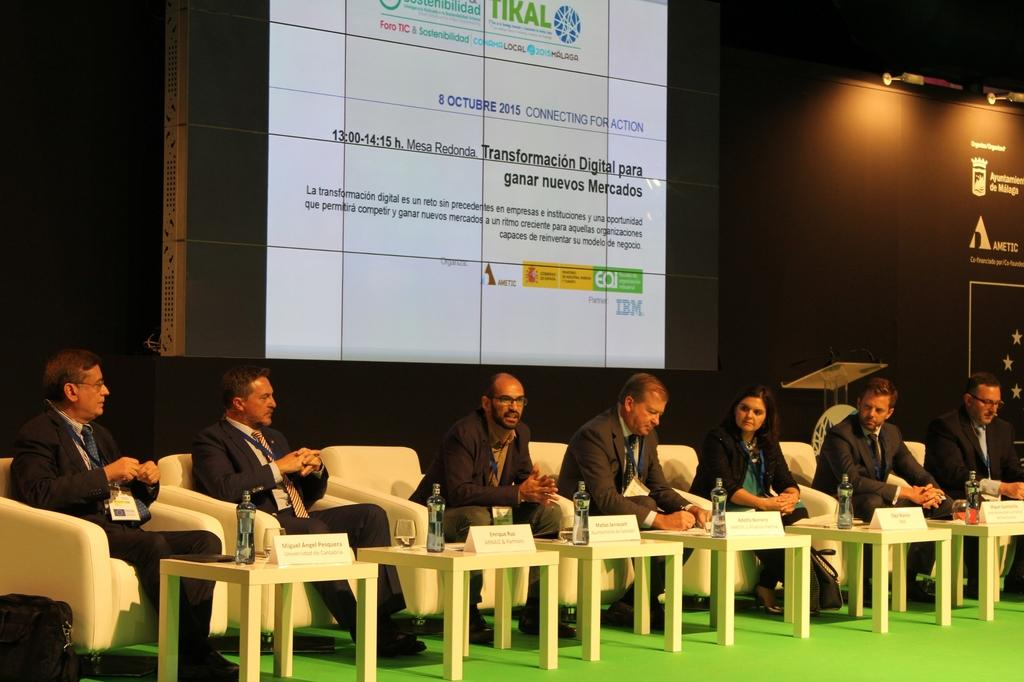What are the people in the image doing? The people in the image are sitting on chairs. What is in front of the chairs? There are tables in front of the chairs. What can be seen on the tables? There is a glass and a bottle on the table. What is visible behind the chairs? There is a banner behind the chairs. What type of planes are flying over the people in the image? There are no planes visible in the image. What base is the banner attached to in the image? The banner is not attached to a base in the image; it is hanging behind the chairs. 